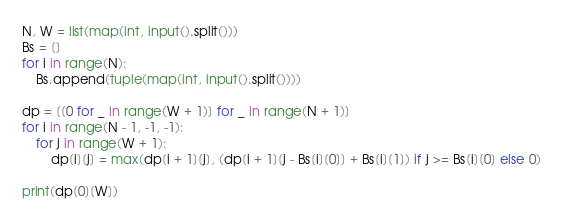<code> <loc_0><loc_0><loc_500><loc_500><_Python_>N, W = list(map(int, input().split()))
Bs = []
for i in range(N):
    Bs.append(tuple(map(int, input().split())))

dp = [[0 for _ in range(W + 1)] for _ in range(N + 1)]
for i in range(N - 1, -1, -1):
    for j in range(W + 1):
        dp[i][j] = max(dp[i + 1][j], (dp[i + 1][j - Bs[i][0]] + Bs[i][1]) if j >= Bs[i][0] else 0)

print(dp[0][W])</code> 